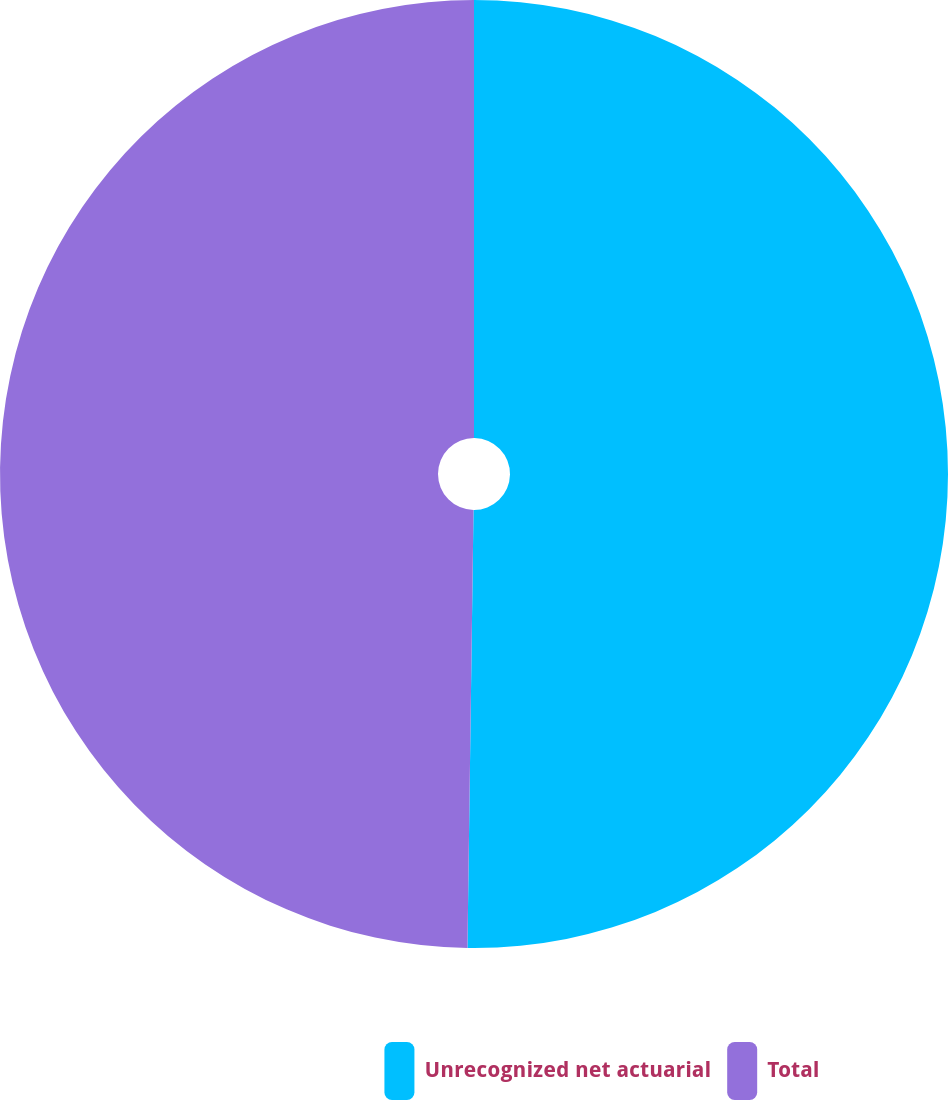Convert chart. <chart><loc_0><loc_0><loc_500><loc_500><pie_chart><fcel>Unrecognized net actuarial<fcel>Total<nl><fcel>50.22%<fcel>49.78%<nl></chart> 